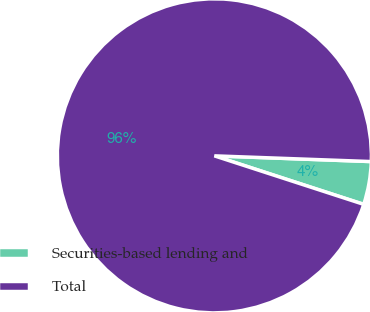<chart> <loc_0><loc_0><loc_500><loc_500><pie_chart><fcel>Securities-based lending and<fcel>Total<nl><fcel>4.42%<fcel>95.58%<nl></chart> 